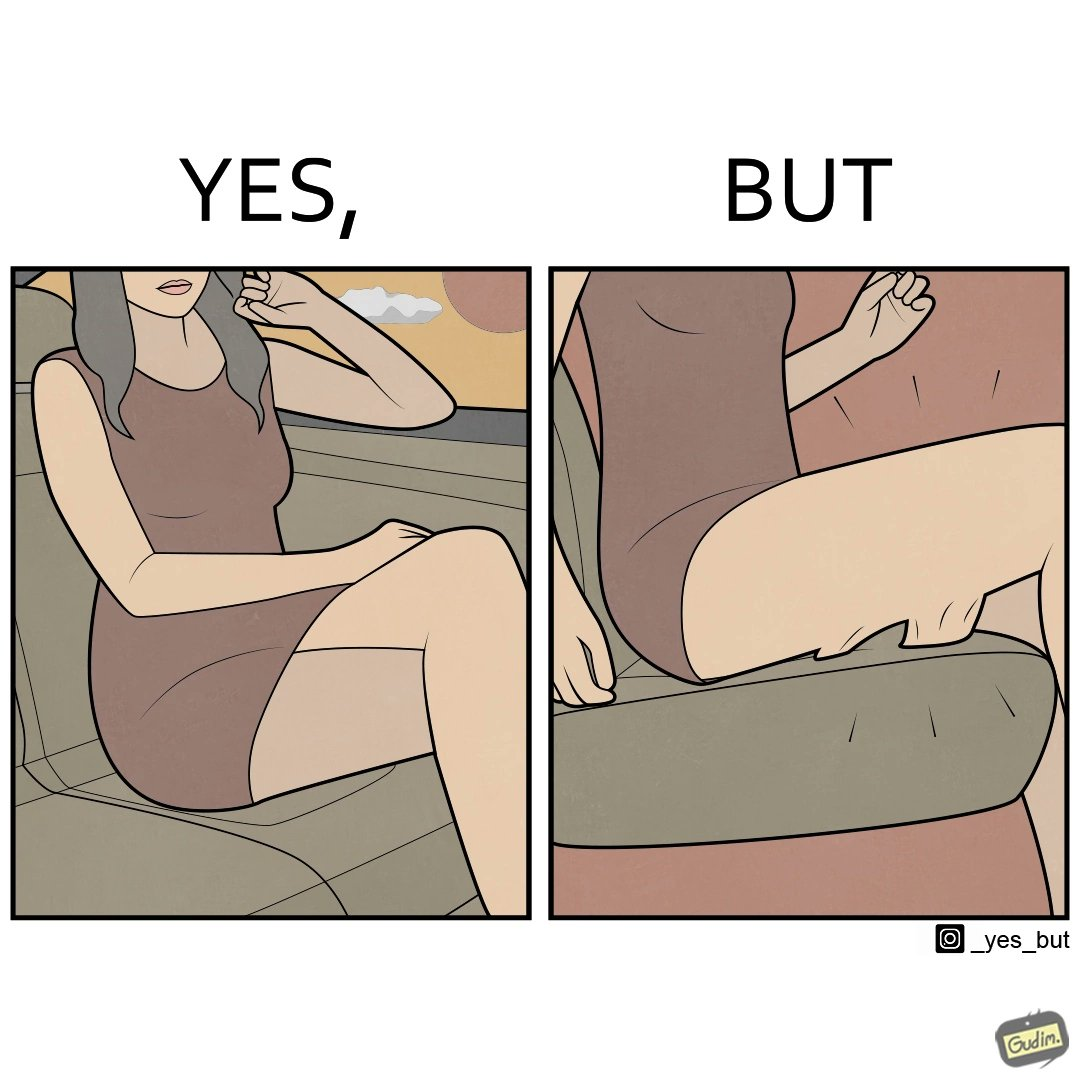What is shown in the left half versus the right half of this image? In the left part of the image: a woman wearing a short dress sitting on the co-passengers seat in a car In the right part of the image: skin of a woman getting sticked to the seat fabric of the car, causing inconvenience 